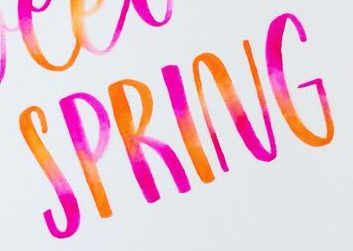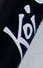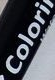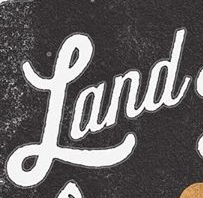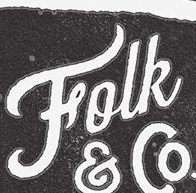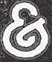What text is displayed in these images sequentially, separated by a semicolon? SPRING; Koi; Colori; Land; Folk; & 